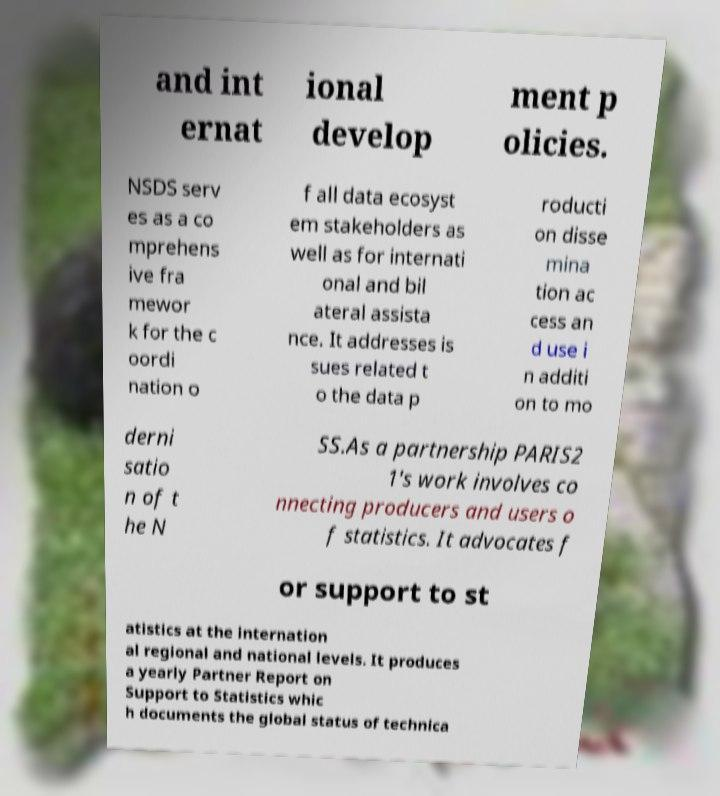Could you extract and type out the text from this image? and int ernat ional develop ment p olicies. NSDS serv es as a co mprehens ive fra mewor k for the c oordi nation o f all data ecosyst em stakeholders as well as for internati onal and bil ateral assista nce. It addresses is sues related t o the data p roducti on disse mina tion ac cess an d use i n additi on to mo derni satio n of t he N SS.As a partnership PARIS2 1's work involves co nnecting producers and users o f statistics. It advocates f or support to st atistics at the internation al regional and national levels. It produces a yearly Partner Report on Support to Statistics whic h documents the global status of technica 